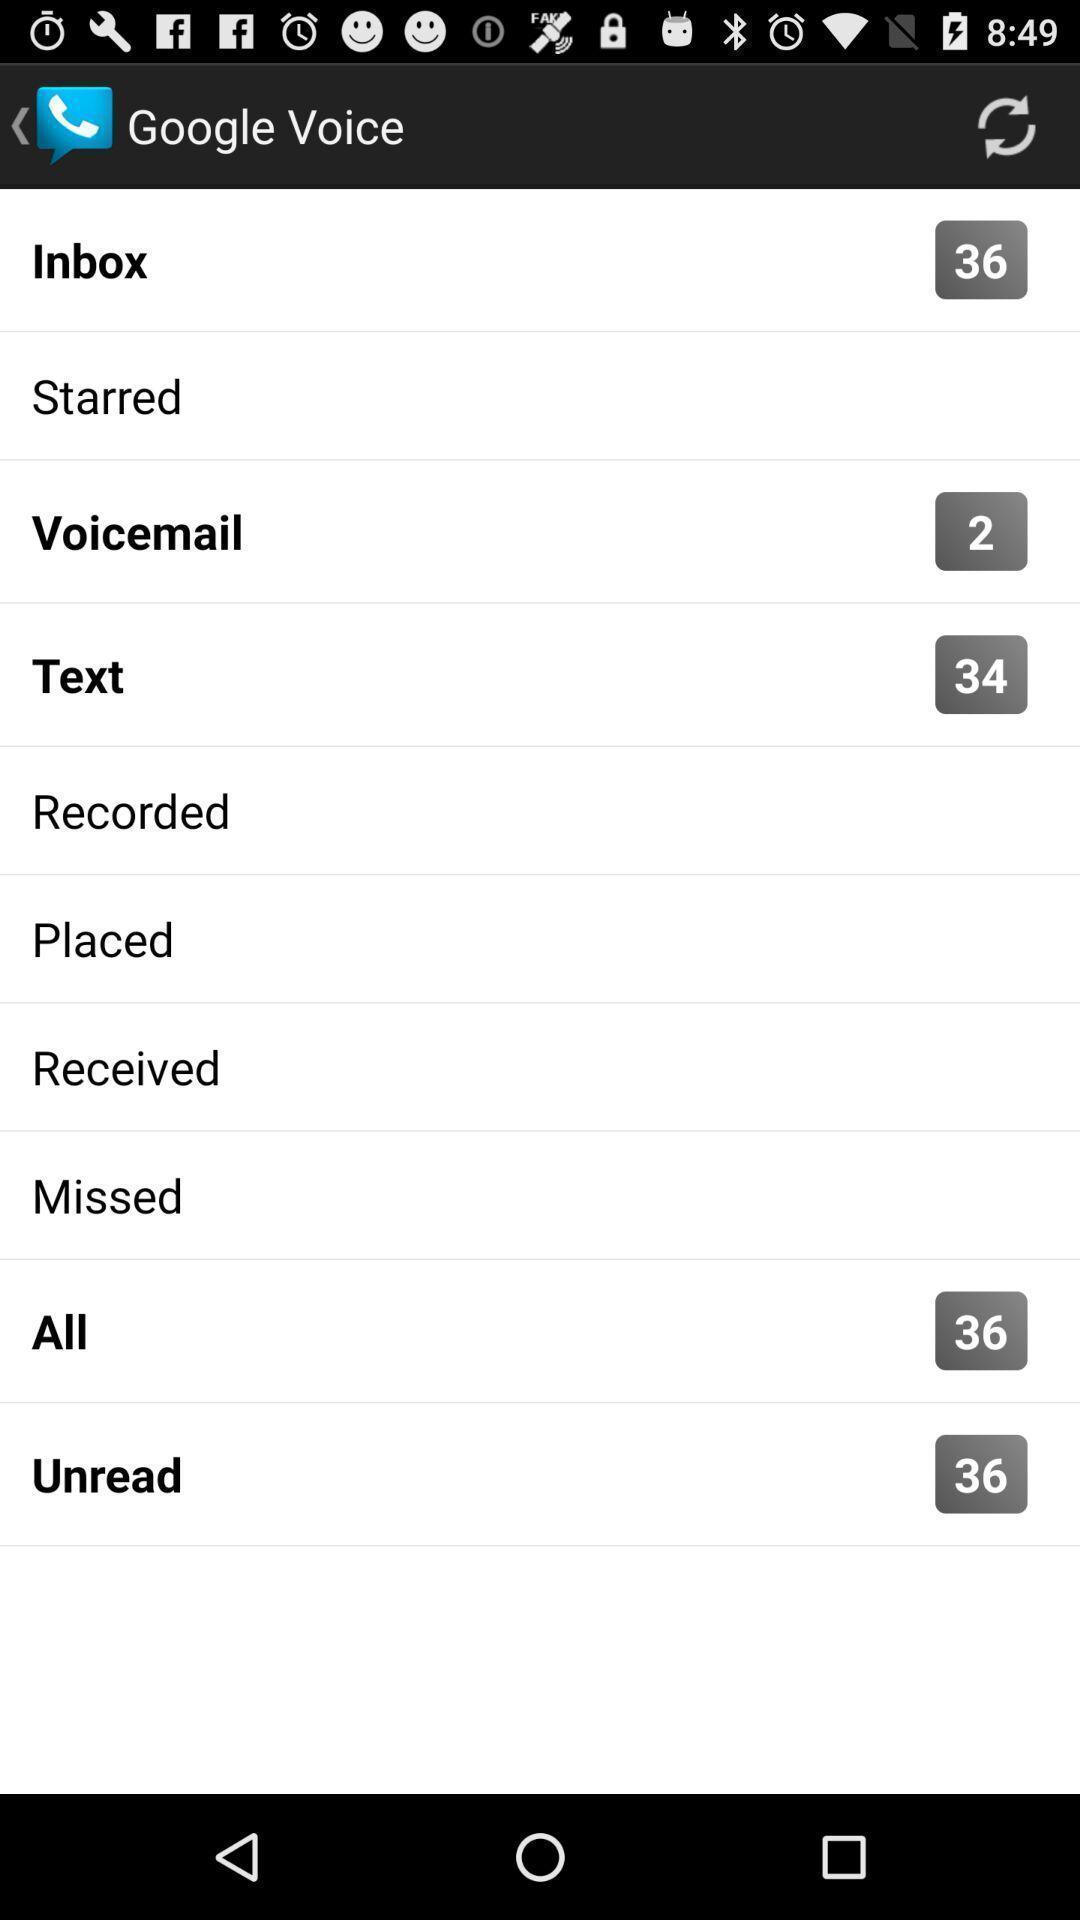Provide a description of this screenshot. Various google voice settings in the application. 